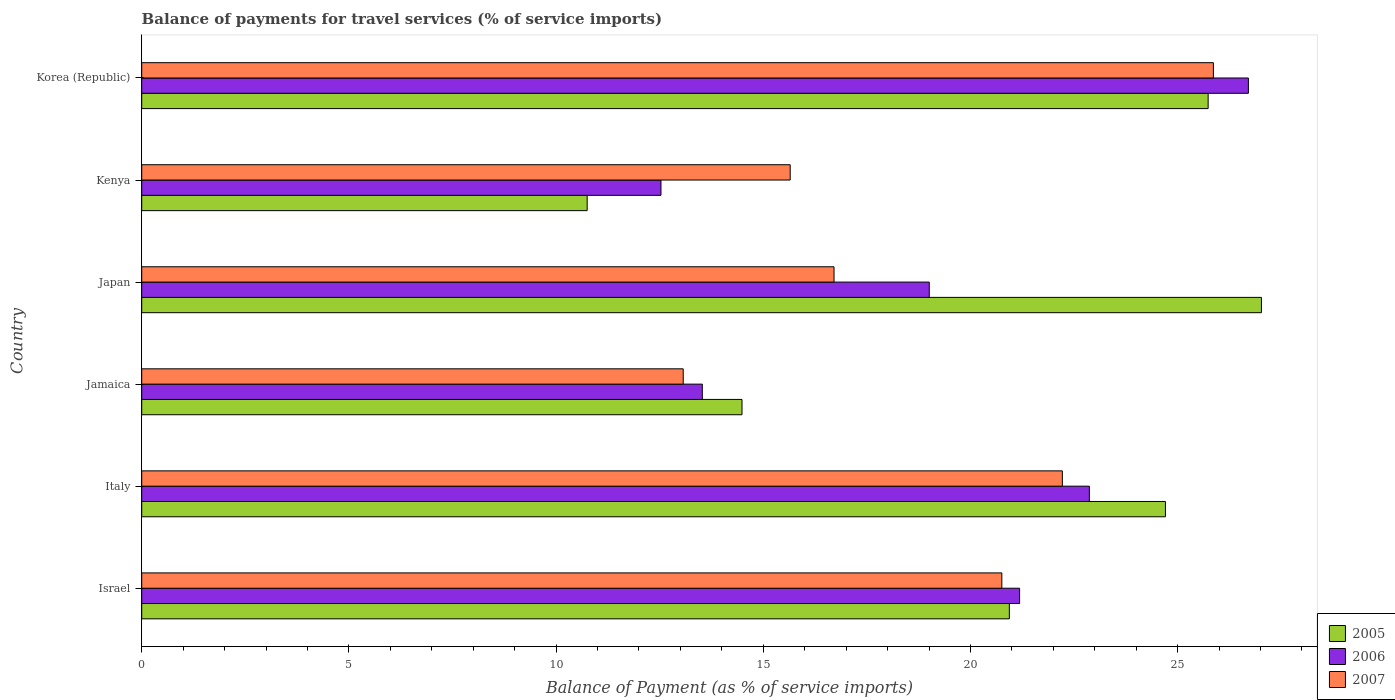How many different coloured bars are there?
Your answer should be compact. 3. Are the number of bars per tick equal to the number of legend labels?
Your answer should be compact. Yes. How many bars are there on the 5th tick from the top?
Offer a terse response. 3. What is the balance of payments for travel services in 2007 in Kenya?
Your response must be concise. 15.65. Across all countries, what is the maximum balance of payments for travel services in 2007?
Make the answer very short. 25.86. Across all countries, what is the minimum balance of payments for travel services in 2007?
Make the answer very short. 13.07. In which country was the balance of payments for travel services in 2005 maximum?
Provide a succinct answer. Japan. In which country was the balance of payments for travel services in 2007 minimum?
Provide a succinct answer. Jamaica. What is the total balance of payments for travel services in 2005 in the graph?
Offer a terse response. 123.64. What is the difference between the balance of payments for travel services in 2006 in Italy and that in Japan?
Your response must be concise. 3.86. What is the difference between the balance of payments for travel services in 2005 in Japan and the balance of payments for travel services in 2006 in Jamaica?
Offer a very short reply. 13.49. What is the average balance of payments for travel services in 2006 per country?
Ensure brevity in your answer.  19.3. What is the difference between the balance of payments for travel services in 2007 and balance of payments for travel services in 2005 in Japan?
Provide a succinct answer. -10.31. What is the ratio of the balance of payments for travel services in 2006 in Italy to that in Jamaica?
Make the answer very short. 1.69. Is the difference between the balance of payments for travel services in 2007 in Japan and Korea (Republic) greater than the difference between the balance of payments for travel services in 2005 in Japan and Korea (Republic)?
Give a very brief answer. No. What is the difference between the highest and the second highest balance of payments for travel services in 2006?
Your response must be concise. 3.84. What is the difference between the highest and the lowest balance of payments for travel services in 2005?
Your answer should be compact. 16.27. Is the sum of the balance of payments for travel services in 2007 in Italy and Kenya greater than the maximum balance of payments for travel services in 2005 across all countries?
Provide a succinct answer. Yes. What does the 1st bar from the bottom in Italy represents?
Your response must be concise. 2005. How many bars are there?
Your answer should be compact. 18. What is the difference between two consecutive major ticks on the X-axis?
Keep it short and to the point. 5. Are the values on the major ticks of X-axis written in scientific E-notation?
Your response must be concise. No. Does the graph contain any zero values?
Your response must be concise. No. What is the title of the graph?
Your answer should be very brief. Balance of payments for travel services (% of service imports). What is the label or title of the X-axis?
Offer a terse response. Balance of Payment (as % of service imports). What is the Balance of Payment (as % of service imports) of 2005 in Israel?
Provide a short and direct response. 20.94. What is the Balance of Payment (as % of service imports) in 2006 in Israel?
Offer a terse response. 21.19. What is the Balance of Payment (as % of service imports) in 2007 in Israel?
Ensure brevity in your answer.  20.76. What is the Balance of Payment (as % of service imports) in 2005 in Italy?
Give a very brief answer. 24.71. What is the Balance of Payment (as % of service imports) of 2006 in Italy?
Make the answer very short. 22.87. What is the Balance of Payment (as % of service imports) in 2007 in Italy?
Offer a terse response. 22.22. What is the Balance of Payment (as % of service imports) in 2005 in Jamaica?
Your answer should be very brief. 14.49. What is the Balance of Payment (as % of service imports) of 2006 in Jamaica?
Give a very brief answer. 13.53. What is the Balance of Payment (as % of service imports) in 2007 in Jamaica?
Your answer should be very brief. 13.07. What is the Balance of Payment (as % of service imports) of 2005 in Japan?
Provide a succinct answer. 27.02. What is the Balance of Payment (as % of service imports) in 2006 in Japan?
Your answer should be very brief. 19.01. What is the Balance of Payment (as % of service imports) of 2007 in Japan?
Ensure brevity in your answer.  16.71. What is the Balance of Payment (as % of service imports) of 2005 in Kenya?
Keep it short and to the point. 10.75. What is the Balance of Payment (as % of service imports) of 2006 in Kenya?
Provide a short and direct response. 12.53. What is the Balance of Payment (as % of service imports) of 2007 in Kenya?
Provide a short and direct response. 15.65. What is the Balance of Payment (as % of service imports) in 2005 in Korea (Republic)?
Make the answer very short. 25.74. What is the Balance of Payment (as % of service imports) of 2006 in Korea (Republic)?
Give a very brief answer. 26.71. What is the Balance of Payment (as % of service imports) in 2007 in Korea (Republic)?
Ensure brevity in your answer.  25.86. Across all countries, what is the maximum Balance of Payment (as % of service imports) in 2005?
Your answer should be very brief. 27.02. Across all countries, what is the maximum Balance of Payment (as % of service imports) of 2006?
Offer a very short reply. 26.71. Across all countries, what is the maximum Balance of Payment (as % of service imports) in 2007?
Give a very brief answer. 25.86. Across all countries, what is the minimum Balance of Payment (as % of service imports) in 2005?
Keep it short and to the point. 10.75. Across all countries, what is the minimum Balance of Payment (as % of service imports) of 2006?
Provide a short and direct response. 12.53. Across all countries, what is the minimum Balance of Payment (as % of service imports) of 2007?
Offer a very short reply. 13.07. What is the total Balance of Payment (as % of service imports) in 2005 in the graph?
Your response must be concise. 123.64. What is the total Balance of Payment (as % of service imports) of 2006 in the graph?
Ensure brevity in your answer.  115.83. What is the total Balance of Payment (as % of service imports) of 2007 in the graph?
Keep it short and to the point. 114.26. What is the difference between the Balance of Payment (as % of service imports) of 2005 in Israel and that in Italy?
Give a very brief answer. -3.77. What is the difference between the Balance of Payment (as % of service imports) in 2006 in Israel and that in Italy?
Provide a succinct answer. -1.68. What is the difference between the Balance of Payment (as % of service imports) in 2007 in Israel and that in Italy?
Offer a terse response. -1.46. What is the difference between the Balance of Payment (as % of service imports) of 2005 in Israel and that in Jamaica?
Provide a succinct answer. 6.45. What is the difference between the Balance of Payment (as % of service imports) in 2006 in Israel and that in Jamaica?
Your answer should be compact. 7.66. What is the difference between the Balance of Payment (as % of service imports) of 2007 in Israel and that in Jamaica?
Your answer should be compact. 7.69. What is the difference between the Balance of Payment (as % of service imports) in 2005 in Israel and that in Japan?
Provide a succinct answer. -6.08. What is the difference between the Balance of Payment (as % of service imports) in 2006 in Israel and that in Japan?
Ensure brevity in your answer.  2.18. What is the difference between the Balance of Payment (as % of service imports) in 2007 in Israel and that in Japan?
Offer a terse response. 4.05. What is the difference between the Balance of Payment (as % of service imports) in 2005 in Israel and that in Kenya?
Give a very brief answer. 10.19. What is the difference between the Balance of Payment (as % of service imports) of 2006 in Israel and that in Kenya?
Ensure brevity in your answer.  8.65. What is the difference between the Balance of Payment (as % of service imports) of 2007 in Israel and that in Kenya?
Provide a succinct answer. 5.11. What is the difference between the Balance of Payment (as % of service imports) in 2005 in Israel and that in Korea (Republic)?
Your answer should be very brief. -4.8. What is the difference between the Balance of Payment (as % of service imports) in 2006 in Israel and that in Korea (Republic)?
Ensure brevity in your answer.  -5.52. What is the difference between the Balance of Payment (as % of service imports) in 2007 in Israel and that in Korea (Republic)?
Your answer should be compact. -5.11. What is the difference between the Balance of Payment (as % of service imports) in 2005 in Italy and that in Jamaica?
Provide a succinct answer. 10.22. What is the difference between the Balance of Payment (as % of service imports) of 2006 in Italy and that in Jamaica?
Your answer should be compact. 9.34. What is the difference between the Balance of Payment (as % of service imports) in 2007 in Italy and that in Jamaica?
Provide a succinct answer. 9.15. What is the difference between the Balance of Payment (as % of service imports) in 2005 in Italy and that in Japan?
Your answer should be very brief. -2.32. What is the difference between the Balance of Payment (as % of service imports) in 2006 in Italy and that in Japan?
Make the answer very short. 3.86. What is the difference between the Balance of Payment (as % of service imports) in 2007 in Italy and that in Japan?
Ensure brevity in your answer.  5.51. What is the difference between the Balance of Payment (as % of service imports) of 2005 in Italy and that in Kenya?
Provide a succinct answer. 13.96. What is the difference between the Balance of Payment (as % of service imports) in 2006 in Italy and that in Kenya?
Your answer should be compact. 10.34. What is the difference between the Balance of Payment (as % of service imports) of 2007 in Italy and that in Kenya?
Your response must be concise. 6.57. What is the difference between the Balance of Payment (as % of service imports) in 2005 in Italy and that in Korea (Republic)?
Provide a short and direct response. -1.03. What is the difference between the Balance of Payment (as % of service imports) of 2006 in Italy and that in Korea (Republic)?
Give a very brief answer. -3.84. What is the difference between the Balance of Payment (as % of service imports) in 2007 in Italy and that in Korea (Republic)?
Your answer should be compact. -3.64. What is the difference between the Balance of Payment (as % of service imports) of 2005 in Jamaica and that in Japan?
Offer a terse response. -12.54. What is the difference between the Balance of Payment (as % of service imports) in 2006 in Jamaica and that in Japan?
Give a very brief answer. -5.48. What is the difference between the Balance of Payment (as % of service imports) in 2007 in Jamaica and that in Japan?
Your response must be concise. -3.64. What is the difference between the Balance of Payment (as % of service imports) of 2005 in Jamaica and that in Kenya?
Keep it short and to the point. 3.74. What is the difference between the Balance of Payment (as % of service imports) of 2007 in Jamaica and that in Kenya?
Ensure brevity in your answer.  -2.58. What is the difference between the Balance of Payment (as % of service imports) in 2005 in Jamaica and that in Korea (Republic)?
Keep it short and to the point. -11.25. What is the difference between the Balance of Payment (as % of service imports) of 2006 in Jamaica and that in Korea (Republic)?
Make the answer very short. -13.18. What is the difference between the Balance of Payment (as % of service imports) in 2007 in Jamaica and that in Korea (Republic)?
Provide a succinct answer. -12.79. What is the difference between the Balance of Payment (as % of service imports) of 2005 in Japan and that in Kenya?
Your response must be concise. 16.27. What is the difference between the Balance of Payment (as % of service imports) of 2006 in Japan and that in Kenya?
Keep it short and to the point. 6.47. What is the difference between the Balance of Payment (as % of service imports) in 2007 in Japan and that in Kenya?
Ensure brevity in your answer.  1.06. What is the difference between the Balance of Payment (as % of service imports) of 2005 in Japan and that in Korea (Republic)?
Offer a terse response. 1.29. What is the difference between the Balance of Payment (as % of service imports) of 2006 in Japan and that in Korea (Republic)?
Give a very brief answer. -7.7. What is the difference between the Balance of Payment (as % of service imports) of 2007 in Japan and that in Korea (Republic)?
Provide a short and direct response. -9.16. What is the difference between the Balance of Payment (as % of service imports) in 2005 in Kenya and that in Korea (Republic)?
Your answer should be compact. -14.99. What is the difference between the Balance of Payment (as % of service imports) of 2006 in Kenya and that in Korea (Republic)?
Keep it short and to the point. -14.18. What is the difference between the Balance of Payment (as % of service imports) of 2007 in Kenya and that in Korea (Republic)?
Make the answer very short. -10.21. What is the difference between the Balance of Payment (as % of service imports) of 2005 in Israel and the Balance of Payment (as % of service imports) of 2006 in Italy?
Offer a very short reply. -1.93. What is the difference between the Balance of Payment (as % of service imports) of 2005 in Israel and the Balance of Payment (as % of service imports) of 2007 in Italy?
Make the answer very short. -1.28. What is the difference between the Balance of Payment (as % of service imports) of 2006 in Israel and the Balance of Payment (as % of service imports) of 2007 in Italy?
Your answer should be very brief. -1.03. What is the difference between the Balance of Payment (as % of service imports) of 2005 in Israel and the Balance of Payment (as % of service imports) of 2006 in Jamaica?
Give a very brief answer. 7.41. What is the difference between the Balance of Payment (as % of service imports) of 2005 in Israel and the Balance of Payment (as % of service imports) of 2007 in Jamaica?
Your answer should be compact. 7.87. What is the difference between the Balance of Payment (as % of service imports) of 2006 in Israel and the Balance of Payment (as % of service imports) of 2007 in Jamaica?
Ensure brevity in your answer.  8.12. What is the difference between the Balance of Payment (as % of service imports) in 2005 in Israel and the Balance of Payment (as % of service imports) in 2006 in Japan?
Keep it short and to the point. 1.93. What is the difference between the Balance of Payment (as % of service imports) in 2005 in Israel and the Balance of Payment (as % of service imports) in 2007 in Japan?
Provide a short and direct response. 4.23. What is the difference between the Balance of Payment (as % of service imports) in 2006 in Israel and the Balance of Payment (as % of service imports) in 2007 in Japan?
Your response must be concise. 4.48. What is the difference between the Balance of Payment (as % of service imports) of 2005 in Israel and the Balance of Payment (as % of service imports) of 2006 in Kenya?
Make the answer very short. 8.41. What is the difference between the Balance of Payment (as % of service imports) of 2005 in Israel and the Balance of Payment (as % of service imports) of 2007 in Kenya?
Give a very brief answer. 5.29. What is the difference between the Balance of Payment (as % of service imports) in 2006 in Israel and the Balance of Payment (as % of service imports) in 2007 in Kenya?
Provide a succinct answer. 5.54. What is the difference between the Balance of Payment (as % of service imports) in 2005 in Israel and the Balance of Payment (as % of service imports) in 2006 in Korea (Republic)?
Provide a short and direct response. -5.77. What is the difference between the Balance of Payment (as % of service imports) of 2005 in Israel and the Balance of Payment (as % of service imports) of 2007 in Korea (Republic)?
Offer a terse response. -4.92. What is the difference between the Balance of Payment (as % of service imports) in 2006 in Israel and the Balance of Payment (as % of service imports) in 2007 in Korea (Republic)?
Offer a very short reply. -4.68. What is the difference between the Balance of Payment (as % of service imports) of 2005 in Italy and the Balance of Payment (as % of service imports) of 2006 in Jamaica?
Ensure brevity in your answer.  11.18. What is the difference between the Balance of Payment (as % of service imports) of 2005 in Italy and the Balance of Payment (as % of service imports) of 2007 in Jamaica?
Ensure brevity in your answer.  11.64. What is the difference between the Balance of Payment (as % of service imports) in 2006 in Italy and the Balance of Payment (as % of service imports) in 2007 in Jamaica?
Keep it short and to the point. 9.8. What is the difference between the Balance of Payment (as % of service imports) in 2005 in Italy and the Balance of Payment (as % of service imports) in 2006 in Japan?
Keep it short and to the point. 5.7. What is the difference between the Balance of Payment (as % of service imports) in 2005 in Italy and the Balance of Payment (as % of service imports) in 2007 in Japan?
Keep it short and to the point. 8. What is the difference between the Balance of Payment (as % of service imports) in 2006 in Italy and the Balance of Payment (as % of service imports) in 2007 in Japan?
Ensure brevity in your answer.  6.16. What is the difference between the Balance of Payment (as % of service imports) in 2005 in Italy and the Balance of Payment (as % of service imports) in 2006 in Kenya?
Offer a terse response. 12.17. What is the difference between the Balance of Payment (as % of service imports) of 2005 in Italy and the Balance of Payment (as % of service imports) of 2007 in Kenya?
Your response must be concise. 9.06. What is the difference between the Balance of Payment (as % of service imports) in 2006 in Italy and the Balance of Payment (as % of service imports) in 2007 in Kenya?
Your response must be concise. 7.22. What is the difference between the Balance of Payment (as % of service imports) of 2005 in Italy and the Balance of Payment (as % of service imports) of 2006 in Korea (Republic)?
Provide a succinct answer. -2. What is the difference between the Balance of Payment (as % of service imports) of 2005 in Italy and the Balance of Payment (as % of service imports) of 2007 in Korea (Republic)?
Provide a succinct answer. -1.16. What is the difference between the Balance of Payment (as % of service imports) of 2006 in Italy and the Balance of Payment (as % of service imports) of 2007 in Korea (Republic)?
Provide a short and direct response. -2.99. What is the difference between the Balance of Payment (as % of service imports) in 2005 in Jamaica and the Balance of Payment (as % of service imports) in 2006 in Japan?
Ensure brevity in your answer.  -4.52. What is the difference between the Balance of Payment (as % of service imports) in 2005 in Jamaica and the Balance of Payment (as % of service imports) in 2007 in Japan?
Your answer should be compact. -2.22. What is the difference between the Balance of Payment (as % of service imports) in 2006 in Jamaica and the Balance of Payment (as % of service imports) in 2007 in Japan?
Offer a very short reply. -3.18. What is the difference between the Balance of Payment (as % of service imports) in 2005 in Jamaica and the Balance of Payment (as % of service imports) in 2006 in Kenya?
Your answer should be compact. 1.96. What is the difference between the Balance of Payment (as % of service imports) of 2005 in Jamaica and the Balance of Payment (as % of service imports) of 2007 in Kenya?
Provide a short and direct response. -1.16. What is the difference between the Balance of Payment (as % of service imports) of 2006 in Jamaica and the Balance of Payment (as % of service imports) of 2007 in Kenya?
Your response must be concise. -2.12. What is the difference between the Balance of Payment (as % of service imports) in 2005 in Jamaica and the Balance of Payment (as % of service imports) in 2006 in Korea (Republic)?
Make the answer very short. -12.22. What is the difference between the Balance of Payment (as % of service imports) of 2005 in Jamaica and the Balance of Payment (as % of service imports) of 2007 in Korea (Republic)?
Your answer should be compact. -11.38. What is the difference between the Balance of Payment (as % of service imports) in 2006 in Jamaica and the Balance of Payment (as % of service imports) in 2007 in Korea (Republic)?
Your response must be concise. -12.33. What is the difference between the Balance of Payment (as % of service imports) in 2005 in Japan and the Balance of Payment (as % of service imports) in 2006 in Kenya?
Keep it short and to the point. 14.49. What is the difference between the Balance of Payment (as % of service imports) of 2005 in Japan and the Balance of Payment (as % of service imports) of 2007 in Kenya?
Provide a short and direct response. 11.37. What is the difference between the Balance of Payment (as % of service imports) of 2006 in Japan and the Balance of Payment (as % of service imports) of 2007 in Kenya?
Your answer should be very brief. 3.36. What is the difference between the Balance of Payment (as % of service imports) of 2005 in Japan and the Balance of Payment (as % of service imports) of 2006 in Korea (Republic)?
Provide a succinct answer. 0.32. What is the difference between the Balance of Payment (as % of service imports) in 2005 in Japan and the Balance of Payment (as % of service imports) in 2007 in Korea (Republic)?
Offer a terse response. 1.16. What is the difference between the Balance of Payment (as % of service imports) in 2006 in Japan and the Balance of Payment (as % of service imports) in 2007 in Korea (Republic)?
Offer a terse response. -6.86. What is the difference between the Balance of Payment (as % of service imports) in 2005 in Kenya and the Balance of Payment (as % of service imports) in 2006 in Korea (Republic)?
Keep it short and to the point. -15.96. What is the difference between the Balance of Payment (as % of service imports) of 2005 in Kenya and the Balance of Payment (as % of service imports) of 2007 in Korea (Republic)?
Offer a very short reply. -15.11. What is the difference between the Balance of Payment (as % of service imports) of 2006 in Kenya and the Balance of Payment (as % of service imports) of 2007 in Korea (Republic)?
Your response must be concise. -13.33. What is the average Balance of Payment (as % of service imports) of 2005 per country?
Make the answer very short. 20.61. What is the average Balance of Payment (as % of service imports) of 2006 per country?
Give a very brief answer. 19.3. What is the average Balance of Payment (as % of service imports) in 2007 per country?
Provide a succinct answer. 19.04. What is the difference between the Balance of Payment (as % of service imports) in 2005 and Balance of Payment (as % of service imports) in 2006 in Israel?
Make the answer very short. -0.25. What is the difference between the Balance of Payment (as % of service imports) in 2005 and Balance of Payment (as % of service imports) in 2007 in Israel?
Your response must be concise. 0.18. What is the difference between the Balance of Payment (as % of service imports) in 2006 and Balance of Payment (as % of service imports) in 2007 in Israel?
Offer a very short reply. 0.43. What is the difference between the Balance of Payment (as % of service imports) of 2005 and Balance of Payment (as % of service imports) of 2006 in Italy?
Give a very brief answer. 1.84. What is the difference between the Balance of Payment (as % of service imports) of 2005 and Balance of Payment (as % of service imports) of 2007 in Italy?
Provide a succinct answer. 2.49. What is the difference between the Balance of Payment (as % of service imports) in 2006 and Balance of Payment (as % of service imports) in 2007 in Italy?
Give a very brief answer. 0.65. What is the difference between the Balance of Payment (as % of service imports) of 2005 and Balance of Payment (as % of service imports) of 2006 in Jamaica?
Provide a short and direct response. 0.96. What is the difference between the Balance of Payment (as % of service imports) of 2005 and Balance of Payment (as % of service imports) of 2007 in Jamaica?
Ensure brevity in your answer.  1.42. What is the difference between the Balance of Payment (as % of service imports) of 2006 and Balance of Payment (as % of service imports) of 2007 in Jamaica?
Your response must be concise. 0.46. What is the difference between the Balance of Payment (as % of service imports) in 2005 and Balance of Payment (as % of service imports) in 2006 in Japan?
Make the answer very short. 8.02. What is the difference between the Balance of Payment (as % of service imports) of 2005 and Balance of Payment (as % of service imports) of 2007 in Japan?
Provide a succinct answer. 10.31. What is the difference between the Balance of Payment (as % of service imports) of 2006 and Balance of Payment (as % of service imports) of 2007 in Japan?
Offer a terse response. 2.3. What is the difference between the Balance of Payment (as % of service imports) in 2005 and Balance of Payment (as % of service imports) in 2006 in Kenya?
Ensure brevity in your answer.  -1.78. What is the difference between the Balance of Payment (as % of service imports) in 2005 and Balance of Payment (as % of service imports) in 2007 in Kenya?
Keep it short and to the point. -4.9. What is the difference between the Balance of Payment (as % of service imports) in 2006 and Balance of Payment (as % of service imports) in 2007 in Kenya?
Ensure brevity in your answer.  -3.12. What is the difference between the Balance of Payment (as % of service imports) of 2005 and Balance of Payment (as % of service imports) of 2006 in Korea (Republic)?
Offer a very short reply. -0.97. What is the difference between the Balance of Payment (as % of service imports) of 2005 and Balance of Payment (as % of service imports) of 2007 in Korea (Republic)?
Provide a succinct answer. -0.13. What is the difference between the Balance of Payment (as % of service imports) of 2006 and Balance of Payment (as % of service imports) of 2007 in Korea (Republic)?
Make the answer very short. 0.84. What is the ratio of the Balance of Payment (as % of service imports) of 2005 in Israel to that in Italy?
Give a very brief answer. 0.85. What is the ratio of the Balance of Payment (as % of service imports) in 2006 in Israel to that in Italy?
Keep it short and to the point. 0.93. What is the ratio of the Balance of Payment (as % of service imports) of 2007 in Israel to that in Italy?
Your answer should be compact. 0.93. What is the ratio of the Balance of Payment (as % of service imports) in 2005 in Israel to that in Jamaica?
Make the answer very short. 1.45. What is the ratio of the Balance of Payment (as % of service imports) in 2006 in Israel to that in Jamaica?
Keep it short and to the point. 1.57. What is the ratio of the Balance of Payment (as % of service imports) of 2007 in Israel to that in Jamaica?
Offer a terse response. 1.59. What is the ratio of the Balance of Payment (as % of service imports) of 2005 in Israel to that in Japan?
Provide a succinct answer. 0.77. What is the ratio of the Balance of Payment (as % of service imports) of 2006 in Israel to that in Japan?
Provide a succinct answer. 1.11. What is the ratio of the Balance of Payment (as % of service imports) of 2007 in Israel to that in Japan?
Ensure brevity in your answer.  1.24. What is the ratio of the Balance of Payment (as % of service imports) in 2005 in Israel to that in Kenya?
Make the answer very short. 1.95. What is the ratio of the Balance of Payment (as % of service imports) of 2006 in Israel to that in Kenya?
Offer a very short reply. 1.69. What is the ratio of the Balance of Payment (as % of service imports) in 2007 in Israel to that in Kenya?
Give a very brief answer. 1.33. What is the ratio of the Balance of Payment (as % of service imports) of 2005 in Israel to that in Korea (Republic)?
Provide a succinct answer. 0.81. What is the ratio of the Balance of Payment (as % of service imports) of 2006 in Israel to that in Korea (Republic)?
Keep it short and to the point. 0.79. What is the ratio of the Balance of Payment (as % of service imports) of 2007 in Israel to that in Korea (Republic)?
Offer a very short reply. 0.8. What is the ratio of the Balance of Payment (as % of service imports) in 2005 in Italy to that in Jamaica?
Ensure brevity in your answer.  1.71. What is the ratio of the Balance of Payment (as % of service imports) in 2006 in Italy to that in Jamaica?
Ensure brevity in your answer.  1.69. What is the ratio of the Balance of Payment (as % of service imports) of 2007 in Italy to that in Jamaica?
Offer a very short reply. 1.7. What is the ratio of the Balance of Payment (as % of service imports) of 2005 in Italy to that in Japan?
Offer a terse response. 0.91. What is the ratio of the Balance of Payment (as % of service imports) in 2006 in Italy to that in Japan?
Provide a succinct answer. 1.2. What is the ratio of the Balance of Payment (as % of service imports) in 2007 in Italy to that in Japan?
Provide a succinct answer. 1.33. What is the ratio of the Balance of Payment (as % of service imports) of 2005 in Italy to that in Kenya?
Your answer should be compact. 2.3. What is the ratio of the Balance of Payment (as % of service imports) in 2006 in Italy to that in Kenya?
Make the answer very short. 1.82. What is the ratio of the Balance of Payment (as % of service imports) in 2007 in Italy to that in Kenya?
Ensure brevity in your answer.  1.42. What is the ratio of the Balance of Payment (as % of service imports) in 2006 in Italy to that in Korea (Republic)?
Ensure brevity in your answer.  0.86. What is the ratio of the Balance of Payment (as % of service imports) in 2007 in Italy to that in Korea (Republic)?
Make the answer very short. 0.86. What is the ratio of the Balance of Payment (as % of service imports) of 2005 in Jamaica to that in Japan?
Provide a short and direct response. 0.54. What is the ratio of the Balance of Payment (as % of service imports) in 2006 in Jamaica to that in Japan?
Make the answer very short. 0.71. What is the ratio of the Balance of Payment (as % of service imports) of 2007 in Jamaica to that in Japan?
Your response must be concise. 0.78. What is the ratio of the Balance of Payment (as % of service imports) in 2005 in Jamaica to that in Kenya?
Give a very brief answer. 1.35. What is the ratio of the Balance of Payment (as % of service imports) in 2006 in Jamaica to that in Kenya?
Provide a short and direct response. 1.08. What is the ratio of the Balance of Payment (as % of service imports) in 2007 in Jamaica to that in Kenya?
Make the answer very short. 0.83. What is the ratio of the Balance of Payment (as % of service imports) in 2005 in Jamaica to that in Korea (Republic)?
Make the answer very short. 0.56. What is the ratio of the Balance of Payment (as % of service imports) of 2006 in Jamaica to that in Korea (Republic)?
Provide a succinct answer. 0.51. What is the ratio of the Balance of Payment (as % of service imports) of 2007 in Jamaica to that in Korea (Republic)?
Your answer should be very brief. 0.51. What is the ratio of the Balance of Payment (as % of service imports) of 2005 in Japan to that in Kenya?
Provide a succinct answer. 2.51. What is the ratio of the Balance of Payment (as % of service imports) in 2006 in Japan to that in Kenya?
Give a very brief answer. 1.52. What is the ratio of the Balance of Payment (as % of service imports) of 2007 in Japan to that in Kenya?
Make the answer very short. 1.07. What is the ratio of the Balance of Payment (as % of service imports) of 2005 in Japan to that in Korea (Republic)?
Provide a succinct answer. 1.05. What is the ratio of the Balance of Payment (as % of service imports) of 2006 in Japan to that in Korea (Republic)?
Your answer should be compact. 0.71. What is the ratio of the Balance of Payment (as % of service imports) of 2007 in Japan to that in Korea (Republic)?
Provide a short and direct response. 0.65. What is the ratio of the Balance of Payment (as % of service imports) of 2005 in Kenya to that in Korea (Republic)?
Offer a very short reply. 0.42. What is the ratio of the Balance of Payment (as % of service imports) in 2006 in Kenya to that in Korea (Republic)?
Offer a very short reply. 0.47. What is the ratio of the Balance of Payment (as % of service imports) in 2007 in Kenya to that in Korea (Republic)?
Provide a short and direct response. 0.61. What is the difference between the highest and the second highest Balance of Payment (as % of service imports) in 2005?
Ensure brevity in your answer.  1.29. What is the difference between the highest and the second highest Balance of Payment (as % of service imports) in 2006?
Your answer should be compact. 3.84. What is the difference between the highest and the second highest Balance of Payment (as % of service imports) of 2007?
Provide a succinct answer. 3.64. What is the difference between the highest and the lowest Balance of Payment (as % of service imports) of 2005?
Make the answer very short. 16.27. What is the difference between the highest and the lowest Balance of Payment (as % of service imports) in 2006?
Offer a very short reply. 14.18. What is the difference between the highest and the lowest Balance of Payment (as % of service imports) in 2007?
Your response must be concise. 12.79. 